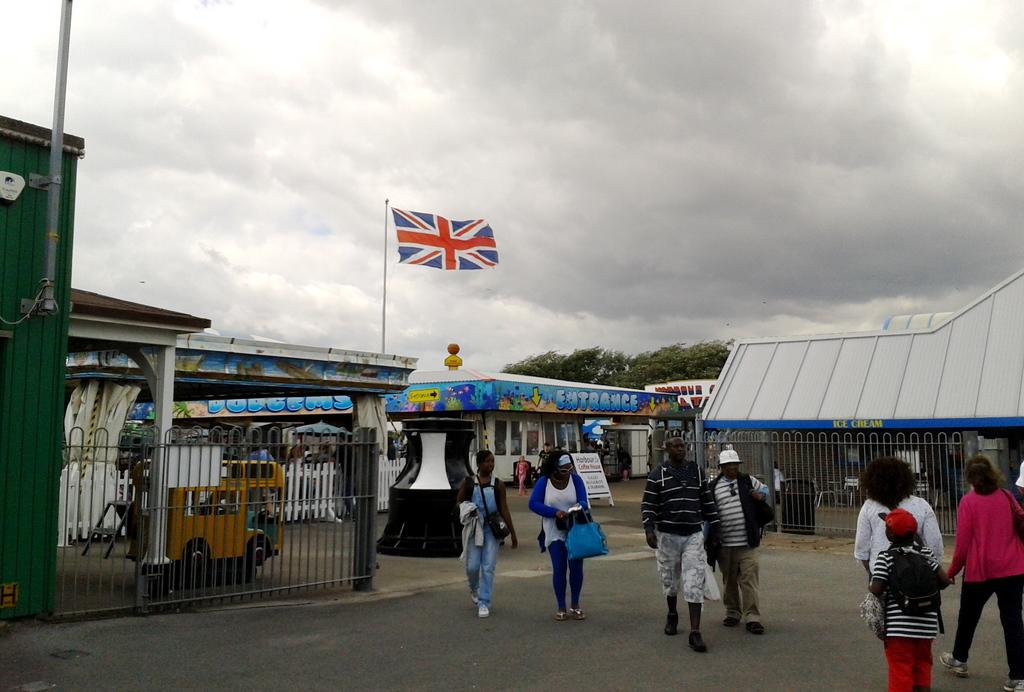Is the entrance visible?
Give a very brief answer. Yes. What is written in yellow to the right?
Ensure brevity in your answer.  Ice cream. 